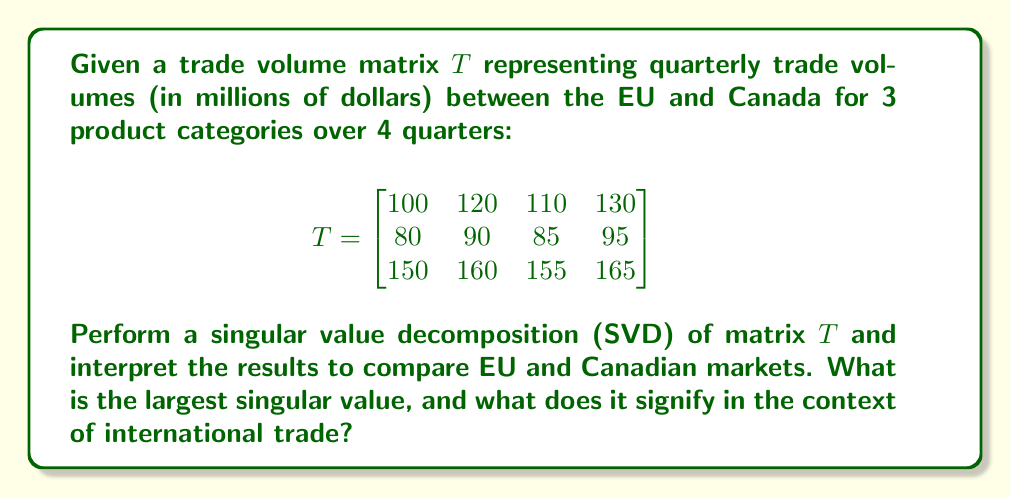Provide a solution to this math problem. To perform SVD on matrix $T$ and interpret the results, we follow these steps:

1) The SVD of matrix $T$ is given by $T = U\Sigma V^T$, where $U$ and $V$ are orthogonal matrices and $\Sigma$ is a diagonal matrix containing the singular values.

2) We use a computational tool to calculate the SVD:

   $U = \begin{bmatrix}
   -0.5196 & -0.8446 & 0.1294 \\
   -0.3775 & 0.1767 & -0.9088 \\
   -0.7664 & 0.5054 & 0.3959
   \end{bmatrix}$

   $\Sigma = \begin{bmatrix}
   539.8246 & 0 & 0 & 0 \\
   0 & 2.4595 & 0 & 0 \\
   0 & 0 & 0.7671 & 0
   \end{bmatrix}$

   $V^T = \begin{bmatrix}
   -0.4897 & -0.5040 & -0.4969 & -0.5092 \\
   -0.7664 & -0.0865 & 0.3211 & 0.5486 \\
   -0.4147 & 0.8592 & -0.2577 & -0.1704 \\
   0 & 0 & 0.7671 & -0.6415
   \end{bmatrix}$

3) The singular values are the diagonal entries of $\Sigma$: 539.8246, 2.4595, and 0.7671.

4) The largest singular value is 539.8246. In the context of international trade, this value represents the overall scale or magnitude of trade volumes between the EU and Canada across all product categories and quarters.

5) The first column of $U$ (-0.5196, -0.3775, -0.7664) represents the relative importance of each product category in the trade relationship. The third category has the highest absolute value, indicating it's the most significant in terms of trade volume.

6) The first row of $V^T$ (-0.4897, -0.5040, -0.4969, -0.5092) shows the relative importance of each quarter. The values are very close, suggesting consistent trade patterns across quarters.

7) The large gap between the first and second singular values (539.8246 vs 2.4595) indicates that the trade relationship is dominated by a single strong pattern, likely representing the overall trade volume trend.
Answer: 539.8246; represents overall scale of EU-Canada trade volumes 